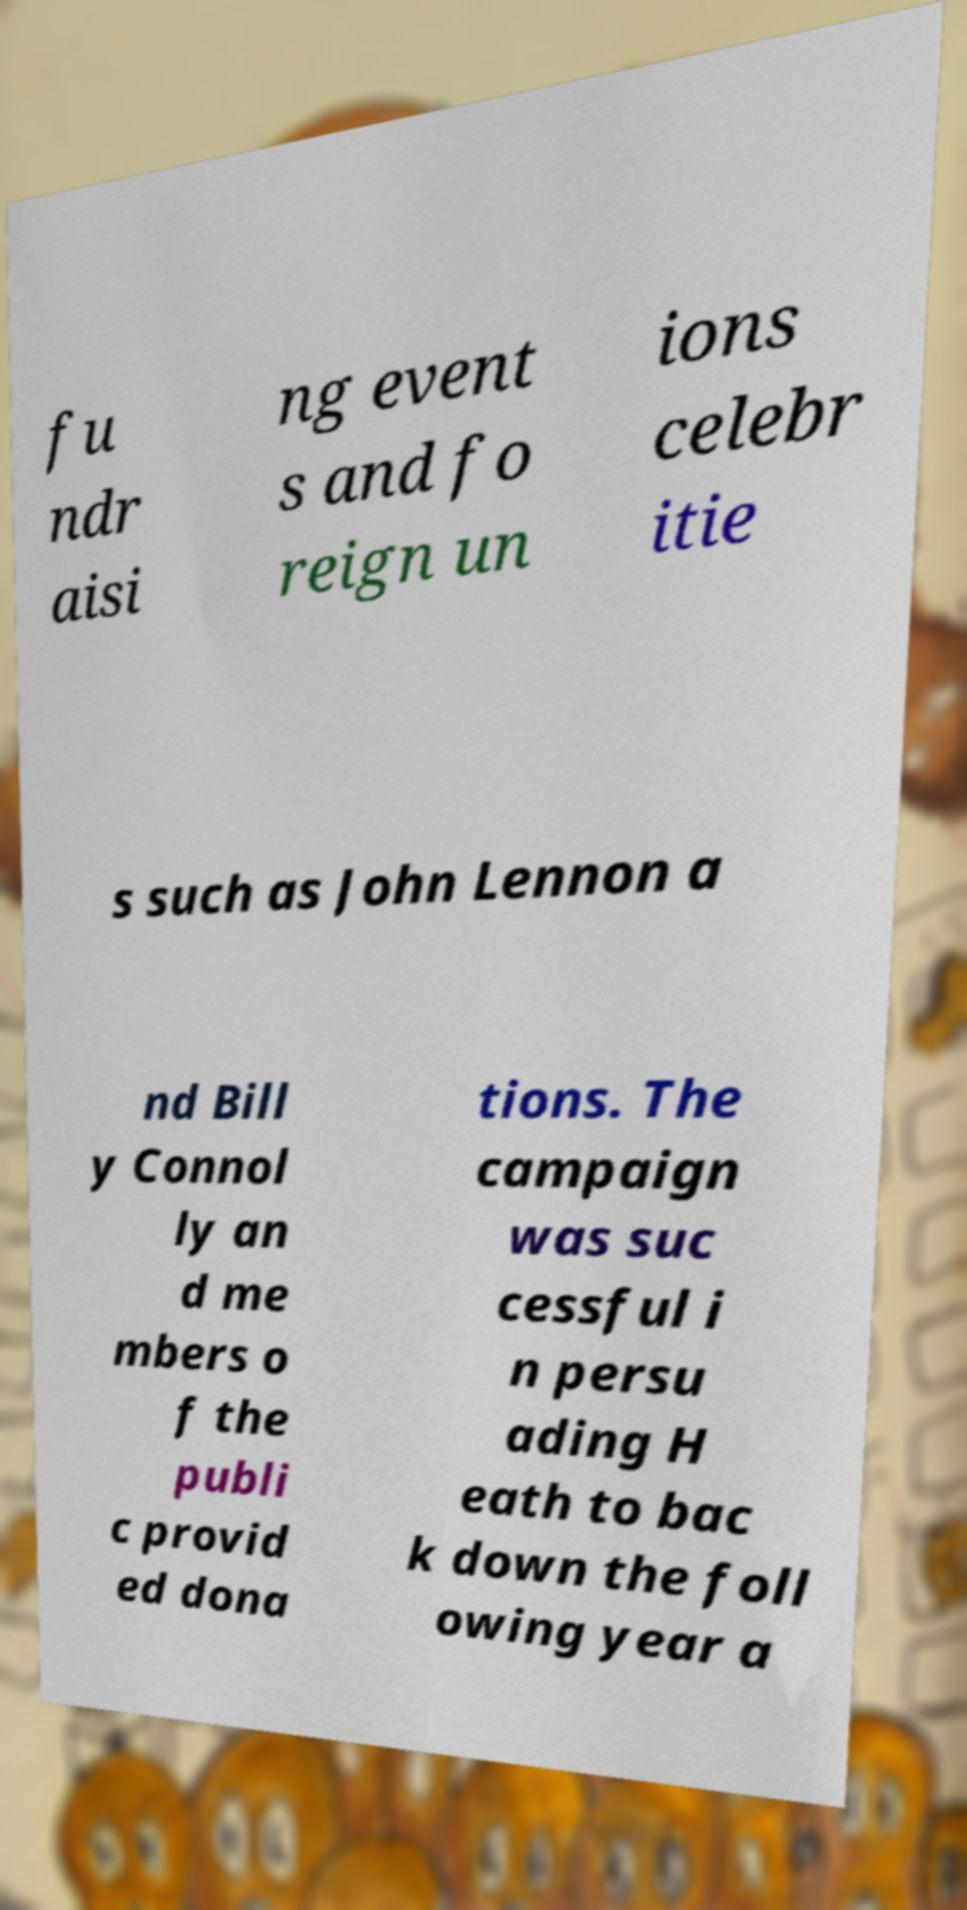Can you read and provide the text displayed in the image?This photo seems to have some interesting text. Can you extract and type it out for me? fu ndr aisi ng event s and fo reign un ions celebr itie s such as John Lennon a nd Bill y Connol ly an d me mbers o f the publi c provid ed dona tions. The campaign was suc cessful i n persu ading H eath to bac k down the foll owing year a 